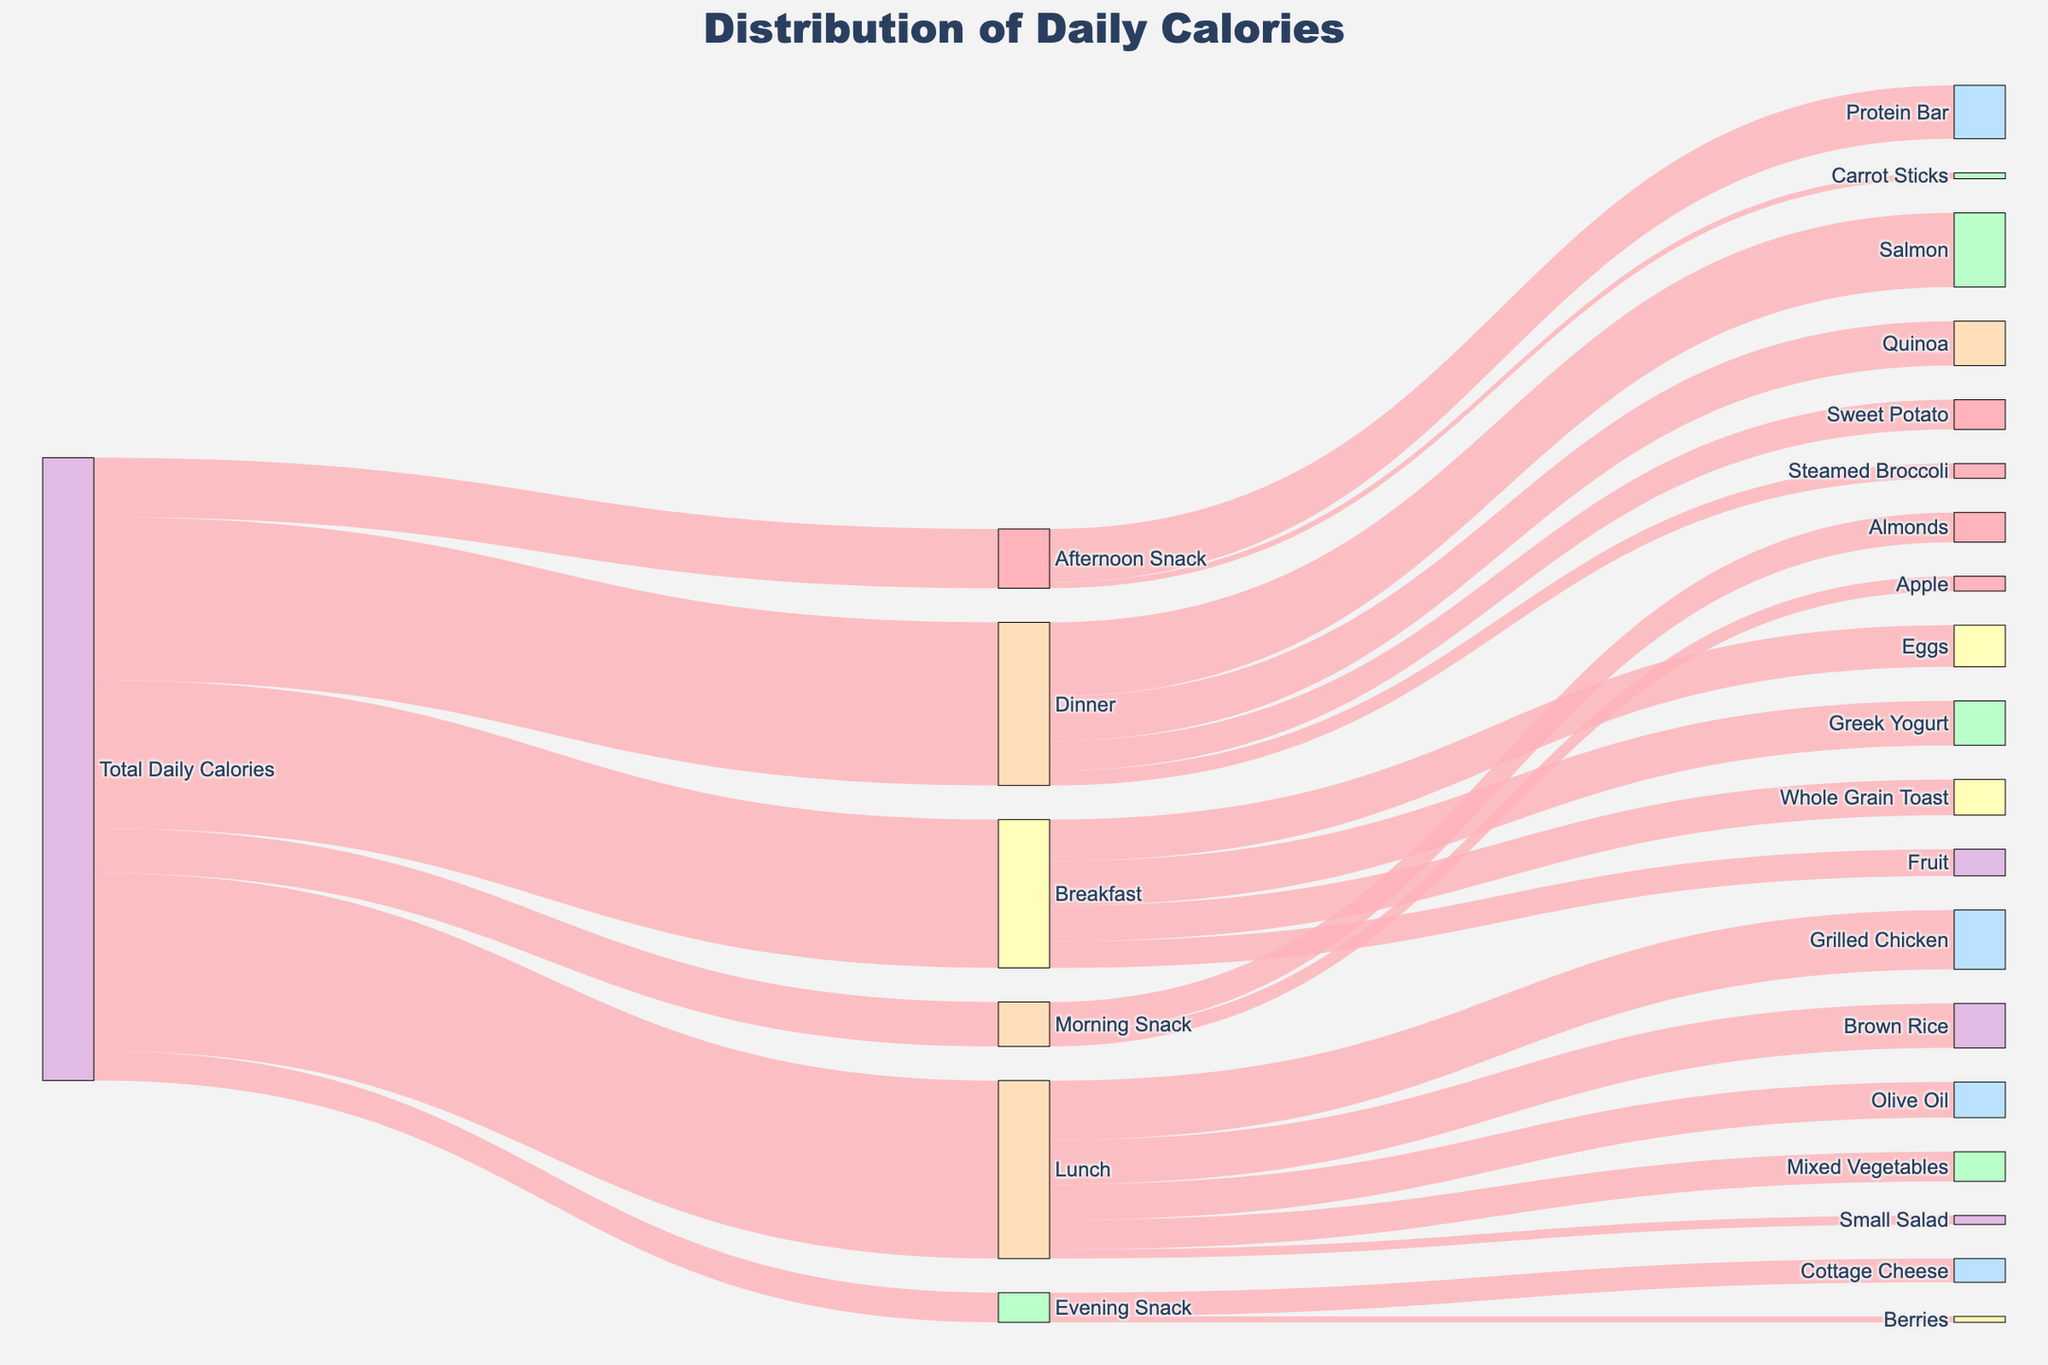What is the title of the figure? The title is usually found at the top of the figure and describes the main idea or objective of the visualization.
Answer: Distribution of Daily Calories How many calories are consumed during Lunch? We look for the label "Lunch" and check the amount connected from "Total Daily Calories" to "Lunch".
Answer: 600 What are the calorie contributions from Breakfast components such as Whole Grain Toast, Eggs, Greek Yogurt, and Fruit? We look for the branches extending from "Breakfast" and sum their values: 120 (Whole Grain Toast) + 140 (Eggs) + 150 (Greek Yogurt) + 90 (Fruit).
Answer: 500 Which snack contains more calories, Almonds in the Morning or Cottage Cheese in the Evening? We compare the value connected from "Morning Snack" to "Almonds" and from "Evening Snack" to "Cottage Cheese".
Answer: Almonds How many calories are contributed by snacks in total throughout the day? Sum the calories of each snack: Morning Snack (150) + Afternoon Snack (200) + Evening Snack (100).
Answer: 450 Which meal or snack comprises the smallest portion of the total calorie intake? We look for the branch with the smallest value connected from "Total Daily Calories", which is "Evening Snack".
Answer: Evening Snack What are the main components contributing to the calories consumed during Dinner? We look for the branches extending from "Dinner" and identify each component: Salmon, Sweet Potato, Steamed Broccoli, and Quinoa.
Answer: Salmon, Sweet Potato, Steamed Broccoli, Quinoa Compare the calorie intake between Breakfast and Dinner. Which is higher? Compare the values from "Total Daily Calories" to "Breakfast" and "Dinner". Breakfast is 500 and Dinner is 550, so Dinner is higher.
Answer: Dinner What is the combined calorie intake for the meals (Breakfast, Lunch, Dinner) excluding snacks? Sum the calories for Breakfast (500), Lunch (600), and Dinner (550).
Answer: 1650 How does the calorie contribution from Grilled Chicken compare to the total calorie intake at Lunch? We look for the proportion of calories from "Grilled Chicken" in the total calories of "Lunch". Grilled Chicken contributes 200 out of 600.
Answer: One-third 